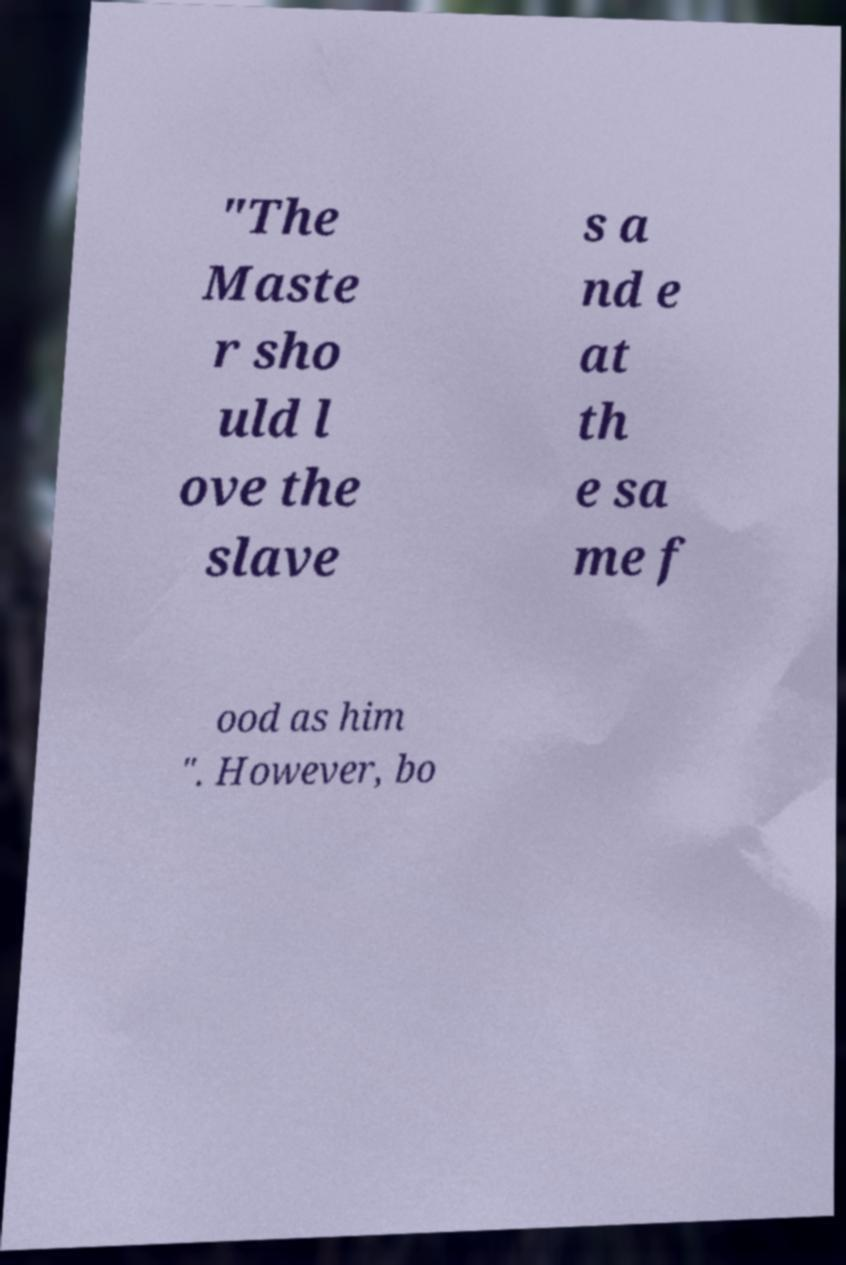There's text embedded in this image that I need extracted. Can you transcribe it verbatim? "The Maste r sho uld l ove the slave s a nd e at th e sa me f ood as him ". However, bo 